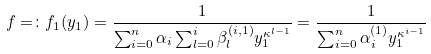<formula> <loc_0><loc_0><loc_500><loc_500>f = \colon f _ { 1 } ( y _ { 1 } ) = \frac { 1 } { \sum _ { i = 0 } ^ { n } \alpha _ { i } \sum _ { l = 0 } ^ { i } \beta _ { l } ^ { ( i , 1 ) } y _ { 1 } ^ { \kappa ^ { l - 1 } } } = \frac { 1 } { \sum _ { i = 0 } ^ { n } \alpha _ { i } ^ { ( 1 ) } y _ { 1 } ^ { \kappa ^ { i - 1 } } }</formula> 